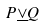<formula> <loc_0><loc_0><loc_500><loc_500>P \underline { \vee } Q</formula> 